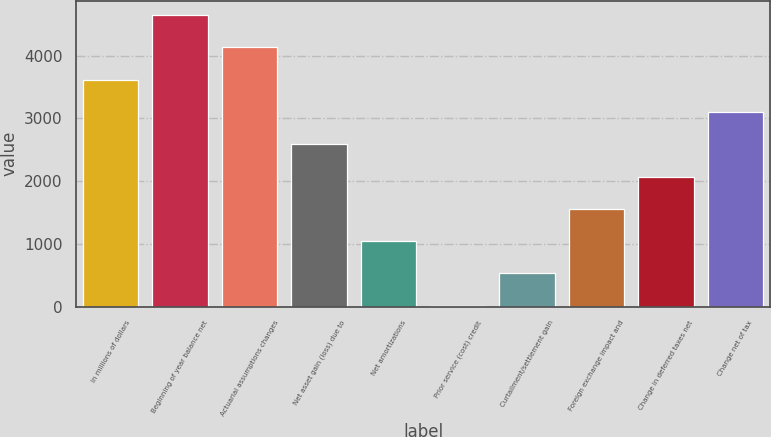Convert chart to OTSL. <chart><loc_0><loc_0><loc_500><loc_500><bar_chart><fcel>In millions of dollars<fcel>Beginning of year balance net<fcel>Actuarial assumptions changes<fcel>Net asset gain (loss) due to<fcel>Net amortizations<fcel>Prior service (cost) credit<fcel>Curtailment/settlement gain<fcel>Foreign exchange impact and<fcel>Change in deferred taxes net<fcel>Change net of tax<nl><fcel>3615.2<fcel>4644.4<fcel>4129.8<fcel>2586<fcel>1042.2<fcel>13<fcel>527.6<fcel>1556.8<fcel>2071.4<fcel>3100.6<nl></chart> 